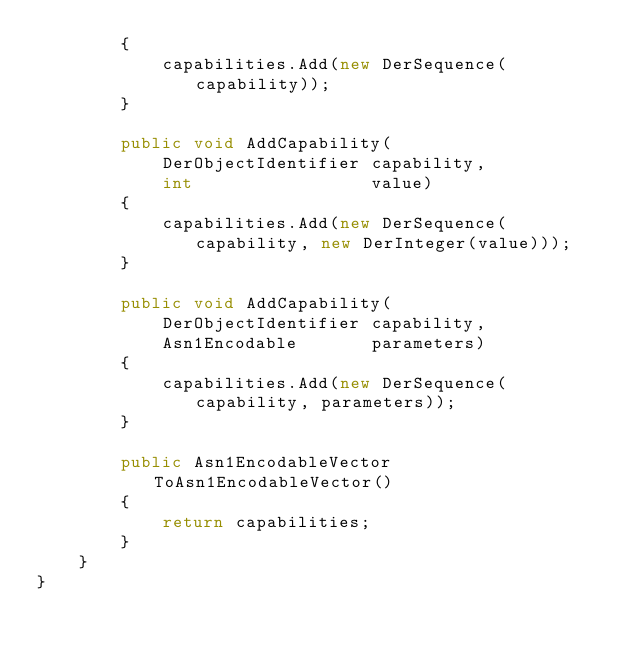Convert code to text. <code><loc_0><loc_0><loc_500><loc_500><_C#_>        {
            capabilities.Add(new DerSequence(capability));
        }

		public void AddCapability(
            DerObjectIdentifier capability,
            int                 value)
        {
			capabilities.Add(new DerSequence(capability, new DerInteger(value)));
        }

		public void AddCapability(
            DerObjectIdentifier capability,
            Asn1Encodable		parameters)
        {
			capabilities.Add(new DerSequence(capability, parameters));
        }

		public Asn1EncodableVector ToAsn1EncodableVector()
        {
            return capabilities;
        }
    }
}
</code> 